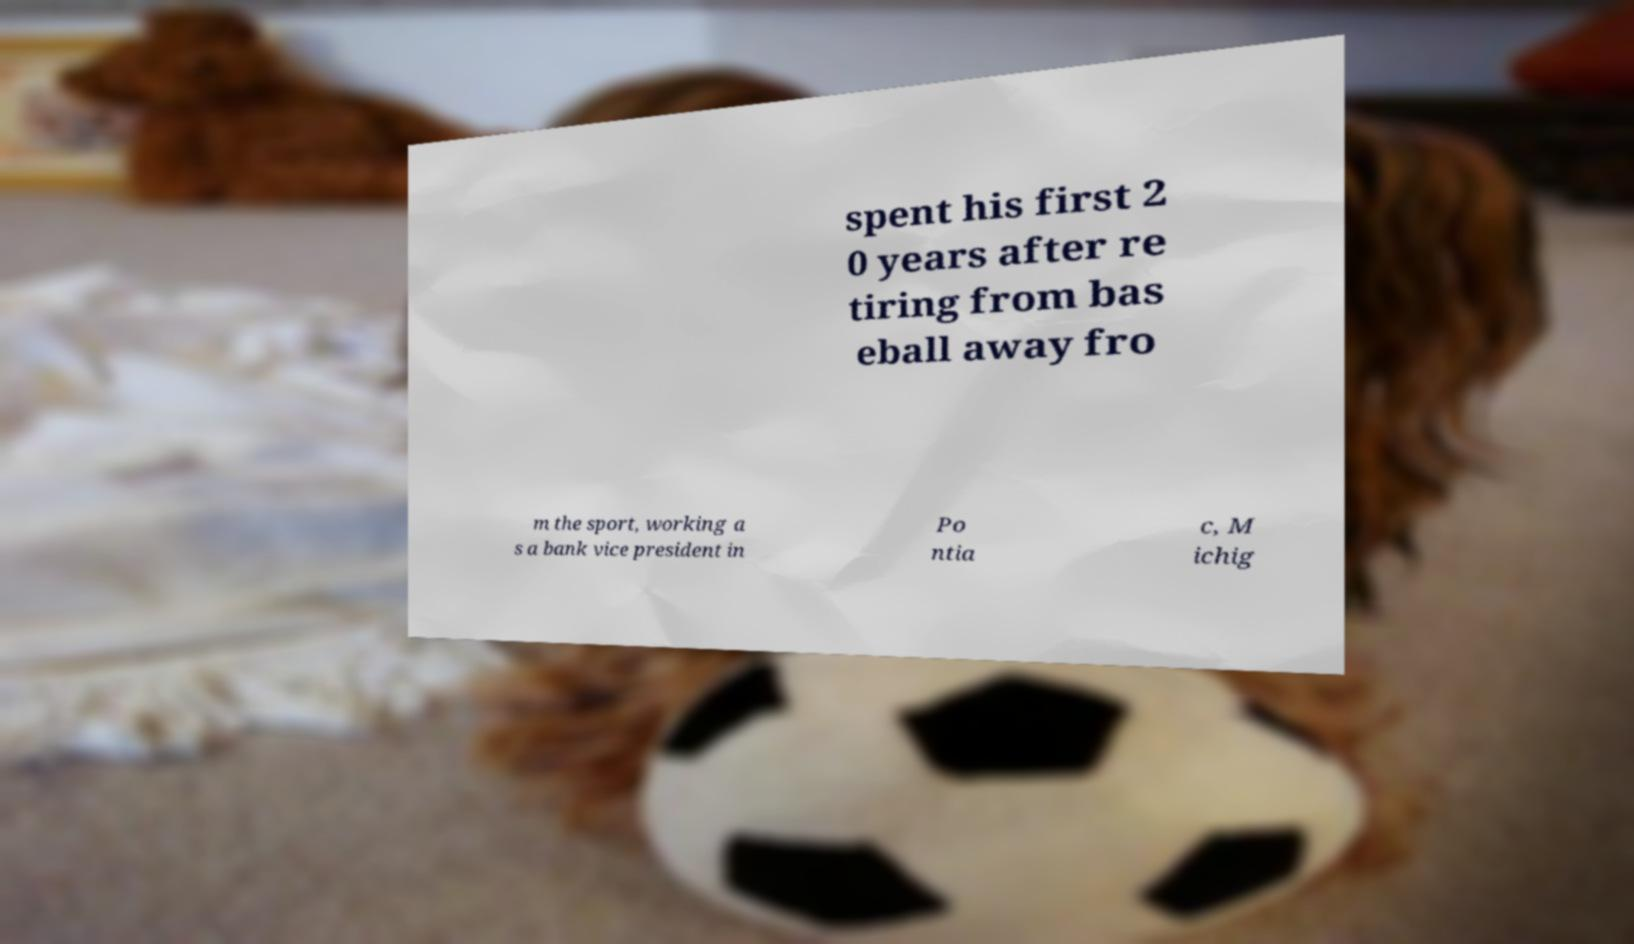Can you read and provide the text displayed in the image?This photo seems to have some interesting text. Can you extract and type it out for me? spent his first 2 0 years after re tiring from bas eball away fro m the sport, working a s a bank vice president in Po ntia c, M ichig 